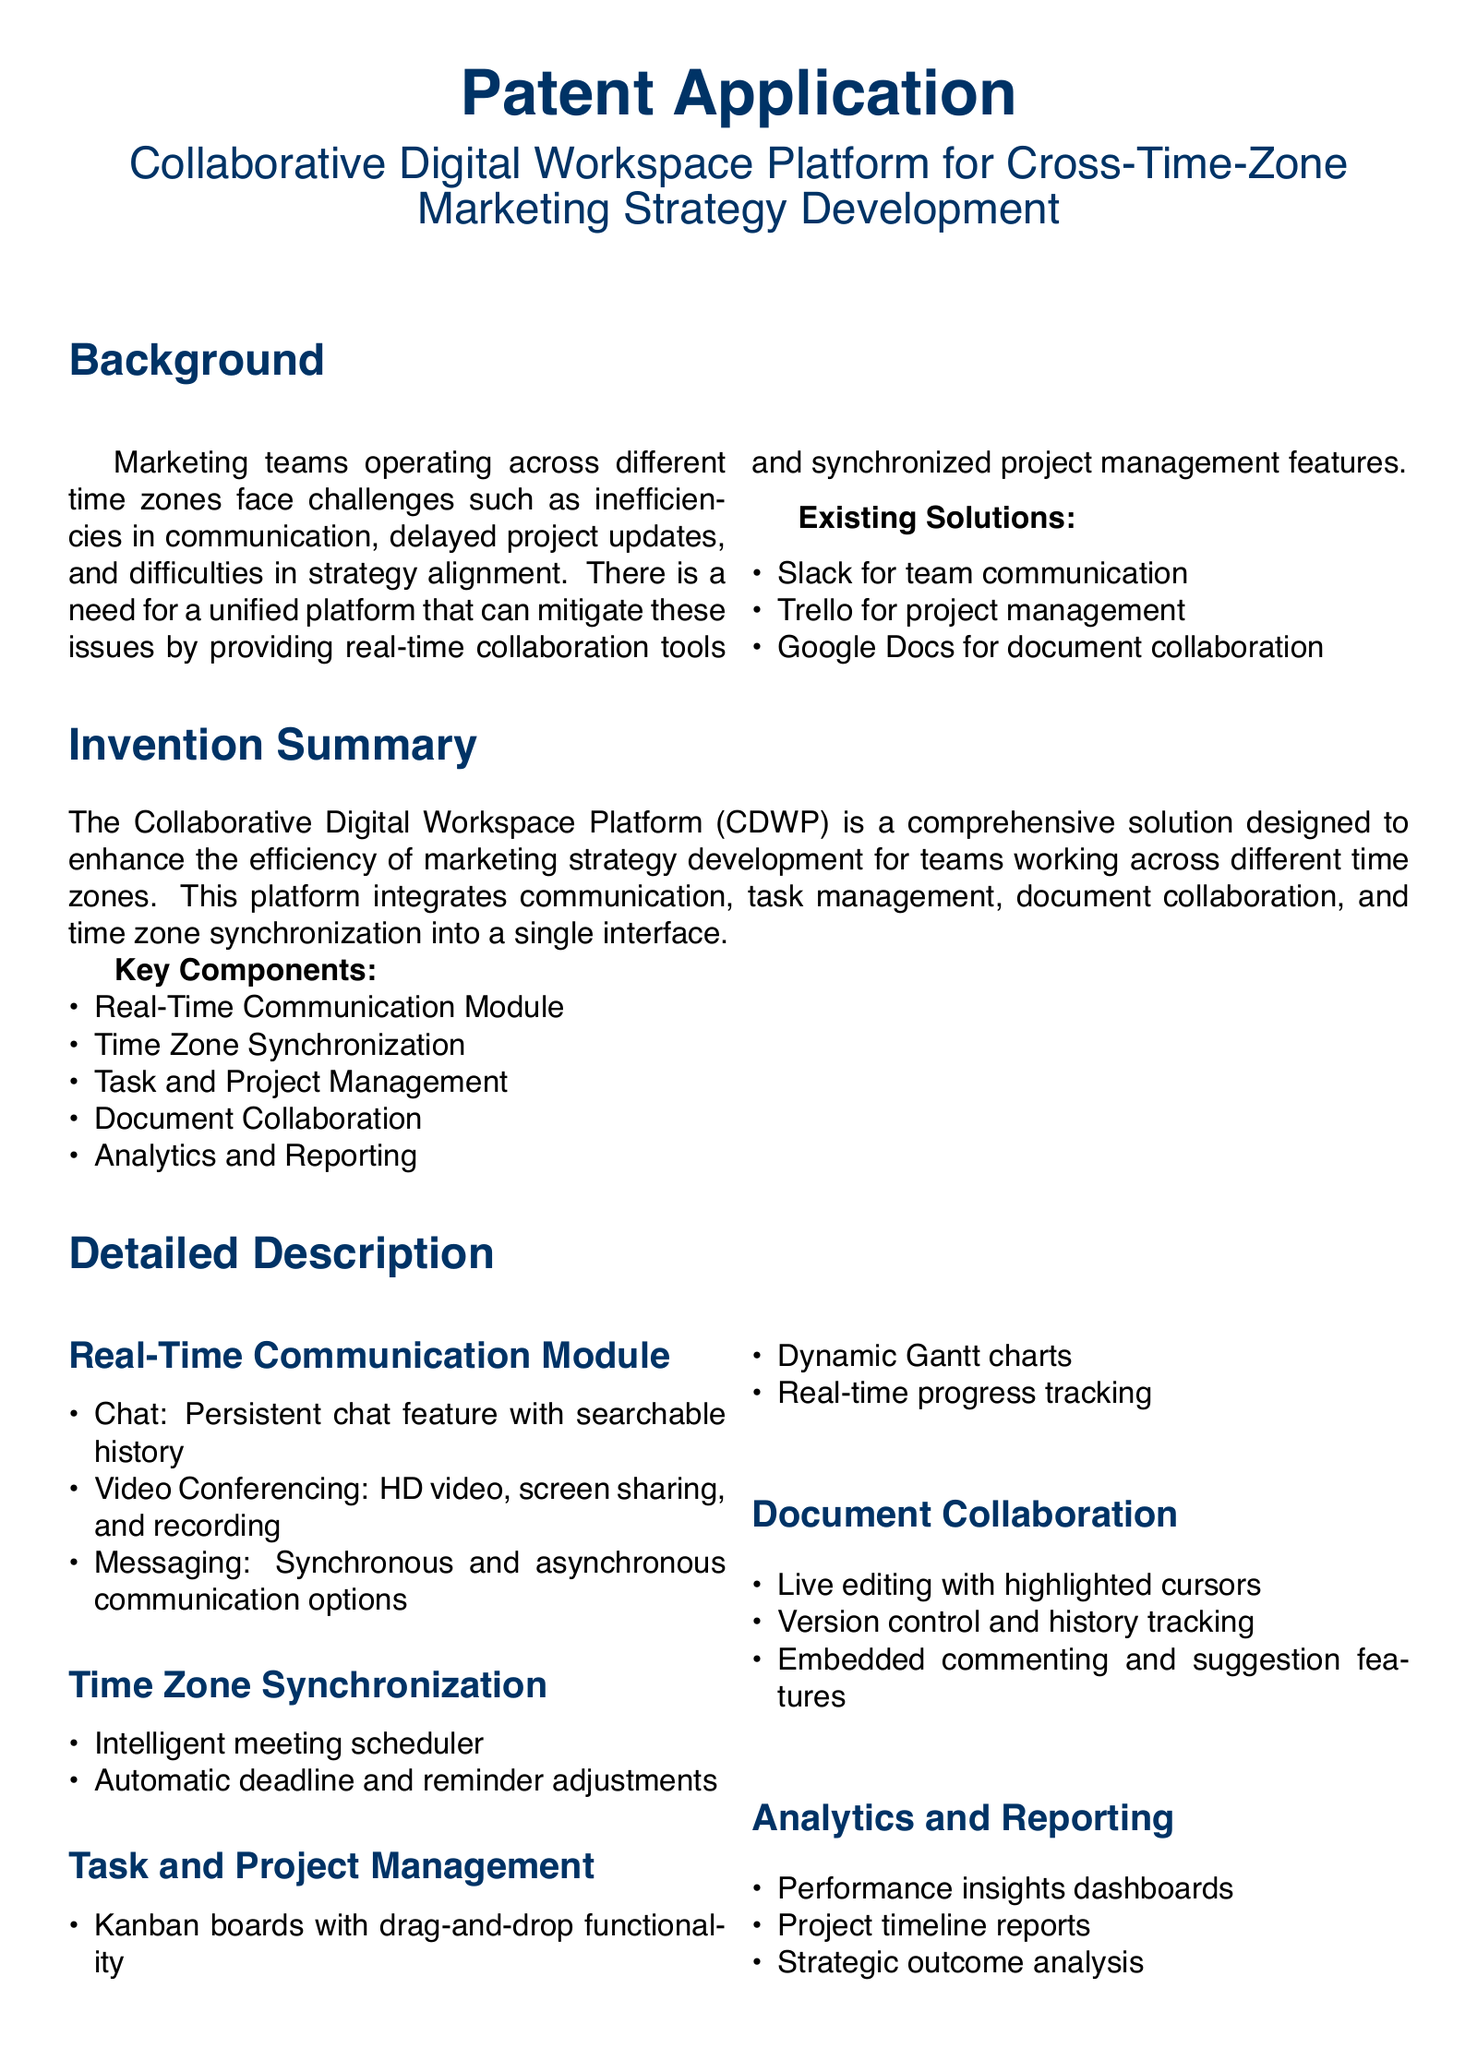What is the title of the patent application? The title is specifically stated at the beginning of the document under the main heading.
Answer: Collaborative Digital Workspace Platform for Cross-Time-Zone Marketing Strategy Development What are the key components listed for the platform? The key components are clearly outlined in a bullet list under the invention summary section.
Answer: Real-Time Communication Module, Time Zone Synchronization, Task and Project Management, Document Collaboration, Analytics and Reporting How many claims are made in this patent application? The number of claims is indicated in the claims section, which lists each claim sequentially.
Answer: Four What is a feature of the Real-Time Communication Module? This information can be found in the detailed description where features are provided for each section.
Answer: Chat What is one proposed future work for the platform? Future work possibilities are noted toward the end of the document, making this information accessible in that section.
Answer: Integration with AI-driven tools for predictive analytics Which existing solution is mentioned for project management? Existing solutions are listed in a bulleted format under the background section, highlighting various tools already in use.
Answer: Trello What does the Time Zone Synchronization feature include? Details about this feature are found in the detailed description, specifically that it has a sub-section addressing its capabilities.
Answer: Intelligent meeting scheduler What does the Analytics and Reporting component provide? The types of insights offered by this component are described in a bullet list under the detailed description.
Answer: Performance insights dashboards 